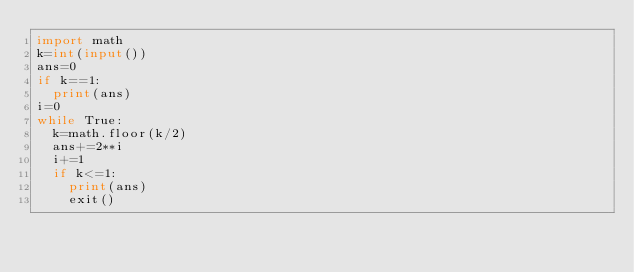<code> <loc_0><loc_0><loc_500><loc_500><_Python_>import math
k=int(input())
ans=0
if k==1:
  print(ans)
i=0
while True:
  k=math.floor(k/2)
  ans+=2**i
  i+=1
  if k<=1:
    print(ans)
    exit()</code> 